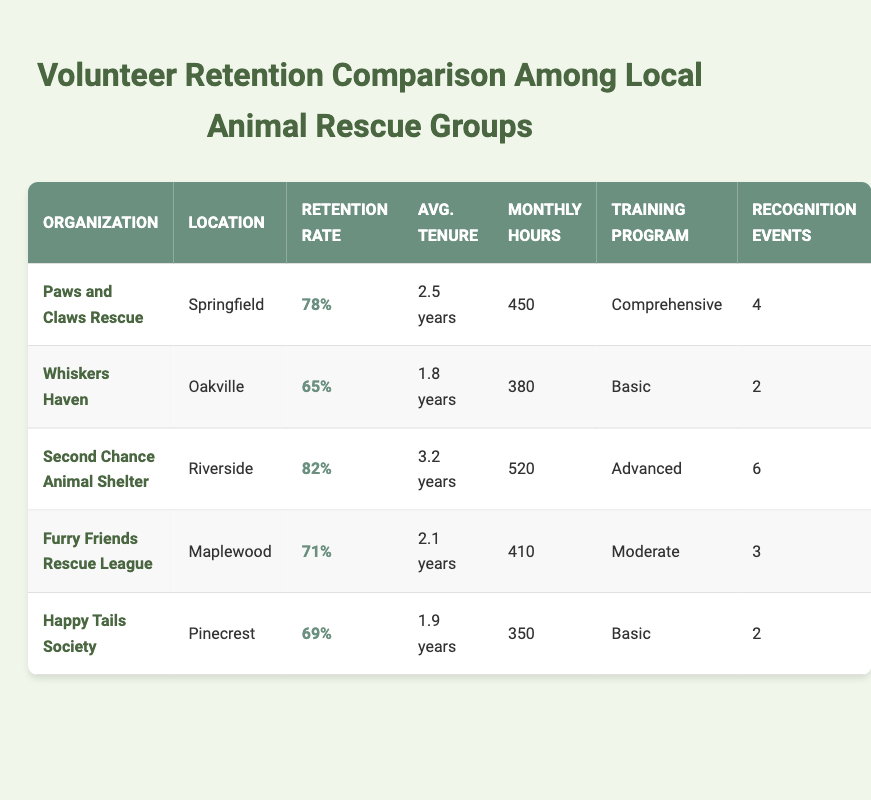What is the volunteer retention rate of Second Chance Animal Shelter? The table lists the volunteer retention rates for each organization. For Second Chance Animal Shelter, the value is provided directly in the table as 82%.
Answer: 82% Which organization has the longest average volunteer tenure? The table includes the average volunteer tenure for each organization. Comparing the values, Second Chance Animal Shelter has the longest tenure of 3.2 years.
Answer: Second Chance Animal Shelter What is the total number of recognition events across all organizations? We can find the recognition events for each organization: Paws and Claws Rescue has 4, Whiskers Haven has 2, Second Chance Animal Shelter has 6, Furry Friends Rescue League has 3, and Happy Tails Society has 2. Adding these gives: 4 + 2 + 6 + 3 + 2 = 17.
Answer: 17 Is the monthly volunteer hour count of Furry Friends Rescue League higher than that of Happy Tails Society? The table states that Furry Friends Rescue League has 410 monthly volunteer hours, while Happy Tails Society has 350. Since 410 is greater than 350, the statement is true.
Answer: Yes Compare the volunteer retention rates of Paws and Claws Rescue and Whiskers Haven. What is the difference between them? Paws and Claws Rescue has a retention rate of 78%, and Whiskers Haven has a rate of 65%. To find the difference, subtract 65% from 78%, which results in 78 - 65 = 13%.
Answer: 13% How many organizations have a volunteer retention rate above 70%? By checking the retention rates in the table, we see that Paws and Claws Rescue (78%), Second Chance Animal Shelter (82%), and Furry Friends Rescue League (71%) have rates above 70%. There are 3 such organizations.
Answer: 3 What is the average monthly volunteer hours among the organizations listed? The monthly hours for the organizations are: 450, 380, 520, 410, and 350. To find the average, we first sum these: 450 + 380 + 520 + 410 + 350 = 2,110. Then divide by the number of organizations, which is 5, giving us 2,110 / 5 = 422.
Answer: 422 Does Happy Tails Society participate in any recognition events? The table shows that Happy Tails Society has 2 recognition events listed. Since this is a positive number, the answer is yes.
Answer: Yes What is the only organization with a "comprehensive" training program? Looking at the training programs listed in the table, only Paws and Claws Rescue has a "comprehensive" training program, while others have different options.
Answer: Paws and Claws Rescue 